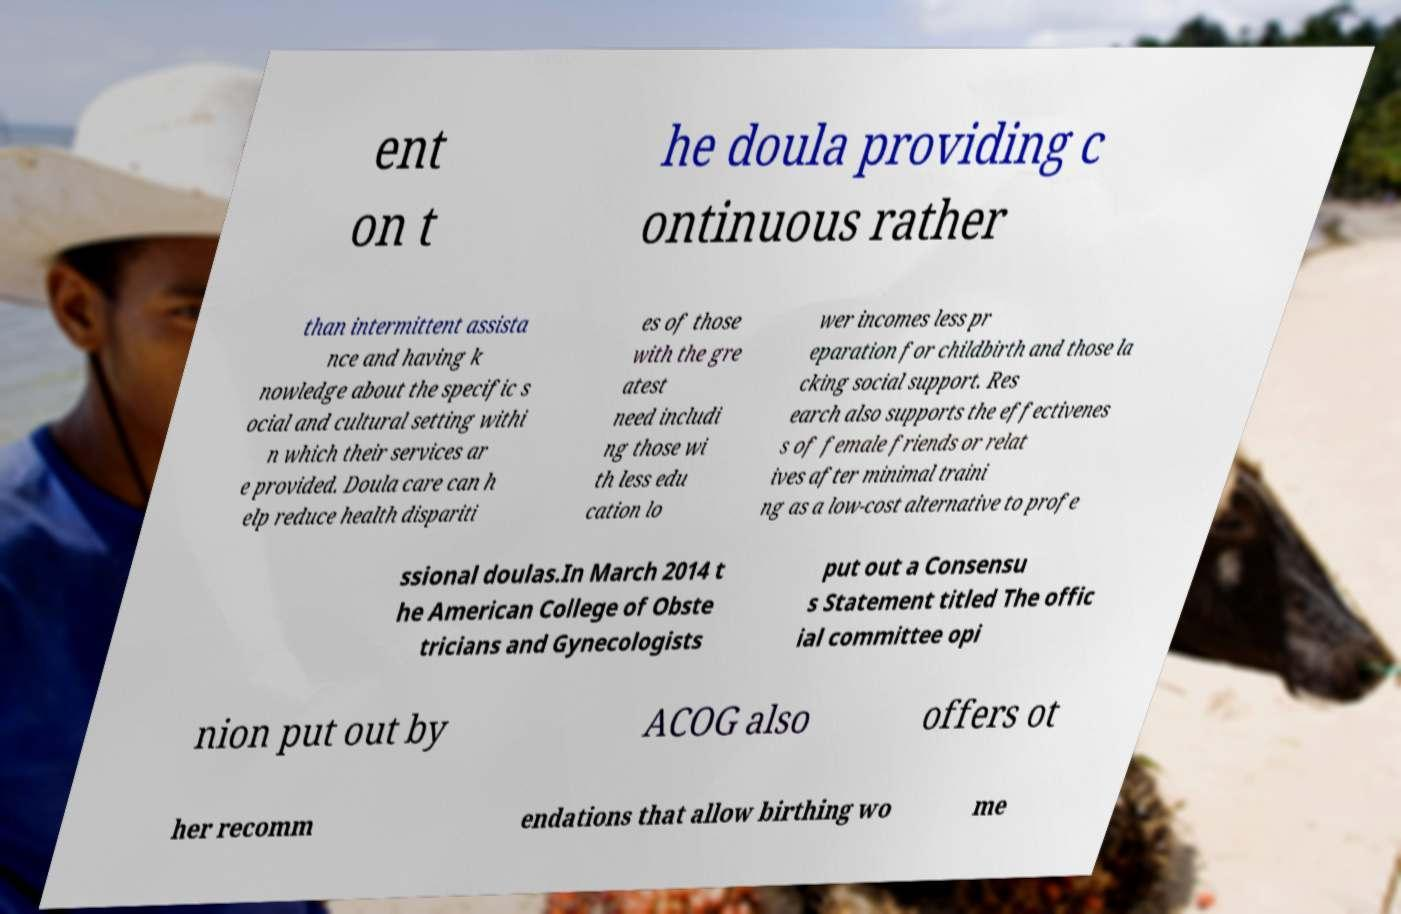Can you accurately transcribe the text from the provided image for me? ent on t he doula providing c ontinuous rather than intermittent assista nce and having k nowledge about the specific s ocial and cultural setting withi n which their services ar e provided. Doula care can h elp reduce health dispariti es of those with the gre atest need includi ng those wi th less edu cation lo wer incomes less pr eparation for childbirth and those la cking social support. Res earch also supports the effectivenes s of female friends or relat ives after minimal traini ng as a low-cost alternative to profe ssional doulas.In March 2014 t he American College of Obste tricians and Gynecologists put out a Consensu s Statement titled The offic ial committee opi nion put out by ACOG also offers ot her recomm endations that allow birthing wo me 